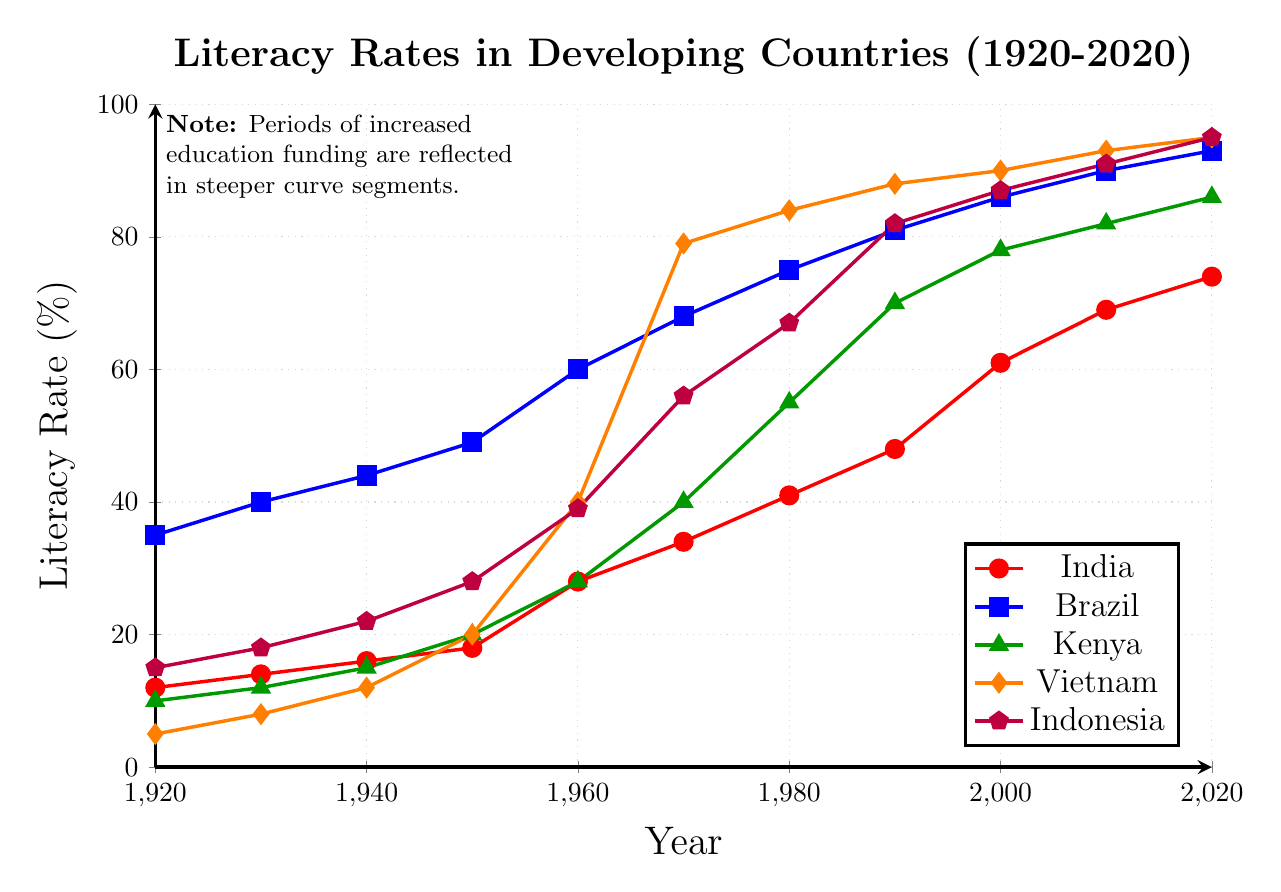Which country had the highest literacy rate in 2020? In 2020, the highest literacy rates are visualized through the heights of the plotted points. From the plot, we see that Vietnam and Indonesia both have literacy rates that reach the top of the chart at 95%.
Answer: Vietnam and Indonesia Between 1960 and 1970, which country experienced the steepest increase in literacy rates? To identify the steepest increase, look for the segment with the largest vertical rise between two consecutive time points. Vietnam's literacy rate increased from 40% in 1960 to 79% in 1970, a 39% increase in 10 years, which is the highest among the countries plotted.
Answer: Vietnam What was the average literacy rate in Brazil in 1940 and 1950? Add the literacy rates for Brazil in 1940 and 1950 and divide by 2. The rates are 44% in 1940 and 49% in 1950, so (44 + 49)/2 = 93/2 = 46.5%.
Answer: 46.5% Compare the literacy rate in Kenya in 1970 to its rate in 2000. By how much did it increase? Identify the literacy rates for Kenya in 1970 and 2000 from the plot, which are 40% and 78% respectively. Subtract the former from the latter. 78 - 40 = 38%.
Answer: 38% In which decade did Indonesia's literacy rate surpass 50%? From the plot, observe the point where Indonesia's literacy rate first goes above the 50% mark. Indonesia's literacy rate in 1960 is 39% and in 1970 is 56%, indicating it surpassed 50% in the 1960s.
Answer: 1960s Which country had the smallest change in literacy rate between 2000 and 2020? Compare the differences in literacy rates for each country between the years 2000 and 2020: 
  - India: 74% - 61% = 13%
  - Brazil: 93% - 86% = 7%
  - Kenya: 86% - 78% = 8%
  - Vietnam: 95% - 90% = 5%
  - Indonesia: 95% - 87% = 8%
Vietnam has the smallest change with a 5% increase.
Answer: Vietnam What is the general trend for literacy rates in developing countries over the past century? Observe the line graphs for all countries. Each line shows a generally increasing trend from 1920 to 2020, indicating that literacy rates in developing countries have been rising over the past century.
Answer: Increasing Identify the year when India's literacy rate reached 40%. Look at the plot and find the year corresponding to the point where India's literacy rate is at 40%. This occurs in 1970, where India's rate is slightly below 40%, and in 1980 it is above 40%, showing it passed 40% around 1980.
Answer: 1980 Among the countries listed, which one reached an 80% literacy rate first? Find the first occurrence where the literacy rate is marked at or above 80% for each country. For Brazil, this happens in 1990. Brazil is the earliest of the countries listed to reach an 80% literacy rate.
Answer: Brazil 